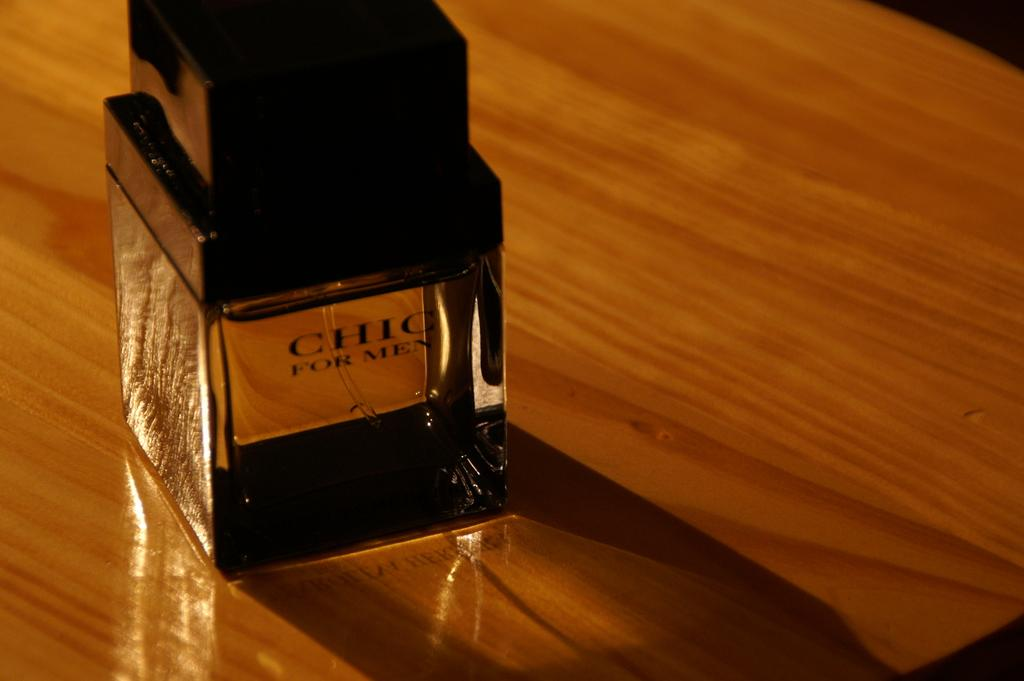<image>
Present a compact description of the photo's key features. A black bottle of Chic for Men sits on a wood table top. 